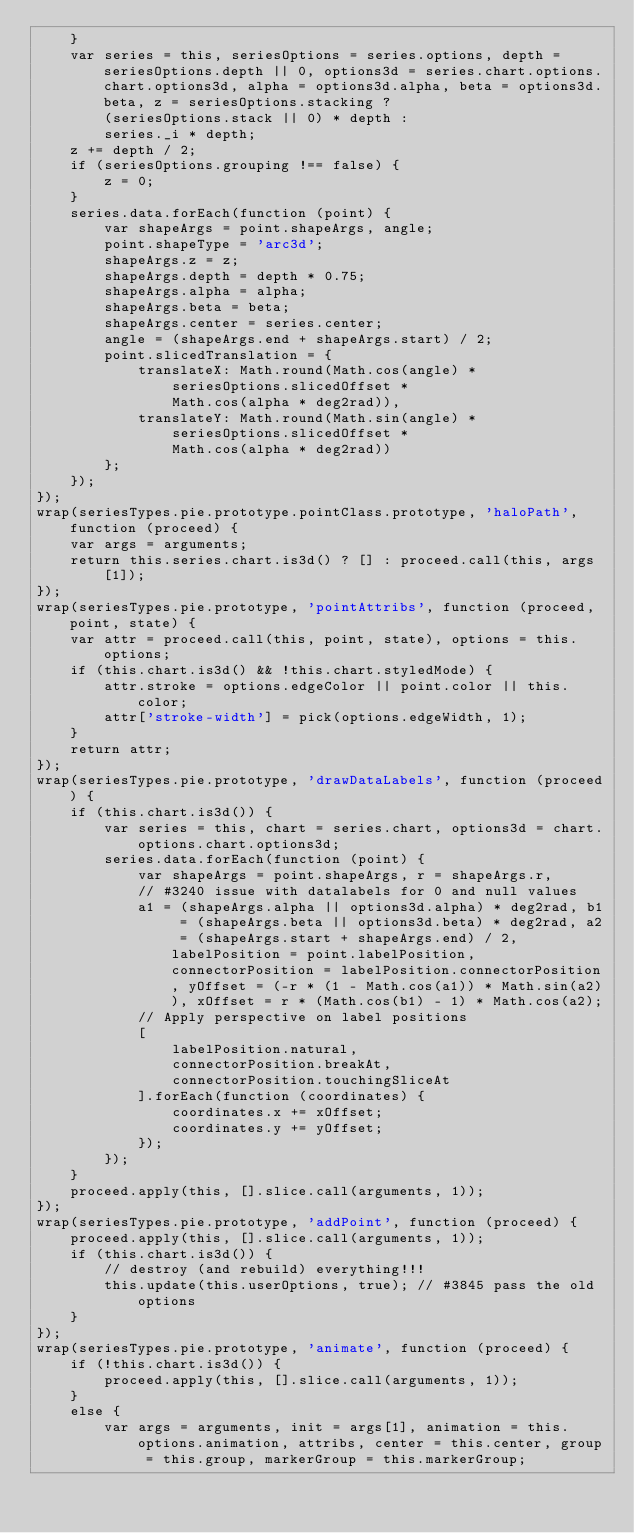Convert code to text. <code><loc_0><loc_0><loc_500><loc_500><_JavaScript_>    }
    var series = this, seriesOptions = series.options, depth = seriesOptions.depth || 0, options3d = series.chart.options.chart.options3d, alpha = options3d.alpha, beta = options3d.beta, z = seriesOptions.stacking ?
        (seriesOptions.stack || 0) * depth :
        series._i * depth;
    z += depth / 2;
    if (seriesOptions.grouping !== false) {
        z = 0;
    }
    series.data.forEach(function (point) {
        var shapeArgs = point.shapeArgs, angle;
        point.shapeType = 'arc3d';
        shapeArgs.z = z;
        shapeArgs.depth = depth * 0.75;
        shapeArgs.alpha = alpha;
        shapeArgs.beta = beta;
        shapeArgs.center = series.center;
        angle = (shapeArgs.end + shapeArgs.start) / 2;
        point.slicedTranslation = {
            translateX: Math.round(Math.cos(angle) *
                seriesOptions.slicedOffset *
                Math.cos(alpha * deg2rad)),
            translateY: Math.round(Math.sin(angle) *
                seriesOptions.slicedOffset *
                Math.cos(alpha * deg2rad))
        };
    });
});
wrap(seriesTypes.pie.prototype.pointClass.prototype, 'haloPath', function (proceed) {
    var args = arguments;
    return this.series.chart.is3d() ? [] : proceed.call(this, args[1]);
});
wrap(seriesTypes.pie.prototype, 'pointAttribs', function (proceed, point, state) {
    var attr = proceed.call(this, point, state), options = this.options;
    if (this.chart.is3d() && !this.chart.styledMode) {
        attr.stroke = options.edgeColor || point.color || this.color;
        attr['stroke-width'] = pick(options.edgeWidth, 1);
    }
    return attr;
});
wrap(seriesTypes.pie.prototype, 'drawDataLabels', function (proceed) {
    if (this.chart.is3d()) {
        var series = this, chart = series.chart, options3d = chart.options.chart.options3d;
        series.data.forEach(function (point) {
            var shapeArgs = point.shapeArgs, r = shapeArgs.r, 
            // #3240 issue with datalabels for 0 and null values
            a1 = (shapeArgs.alpha || options3d.alpha) * deg2rad, b1 = (shapeArgs.beta || options3d.beta) * deg2rad, a2 = (shapeArgs.start + shapeArgs.end) / 2, labelPosition = point.labelPosition, connectorPosition = labelPosition.connectorPosition, yOffset = (-r * (1 - Math.cos(a1)) * Math.sin(a2)), xOffset = r * (Math.cos(b1) - 1) * Math.cos(a2);
            // Apply perspective on label positions
            [
                labelPosition.natural,
                connectorPosition.breakAt,
                connectorPosition.touchingSliceAt
            ].forEach(function (coordinates) {
                coordinates.x += xOffset;
                coordinates.y += yOffset;
            });
        });
    }
    proceed.apply(this, [].slice.call(arguments, 1));
});
wrap(seriesTypes.pie.prototype, 'addPoint', function (proceed) {
    proceed.apply(this, [].slice.call(arguments, 1));
    if (this.chart.is3d()) {
        // destroy (and rebuild) everything!!!
        this.update(this.userOptions, true); // #3845 pass the old options
    }
});
wrap(seriesTypes.pie.prototype, 'animate', function (proceed) {
    if (!this.chart.is3d()) {
        proceed.apply(this, [].slice.call(arguments, 1));
    }
    else {
        var args = arguments, init = args[1], animation = this.options.animation, attribs, center = this.center, group = this.group, markerGroup = this.markerGroup;</code> 